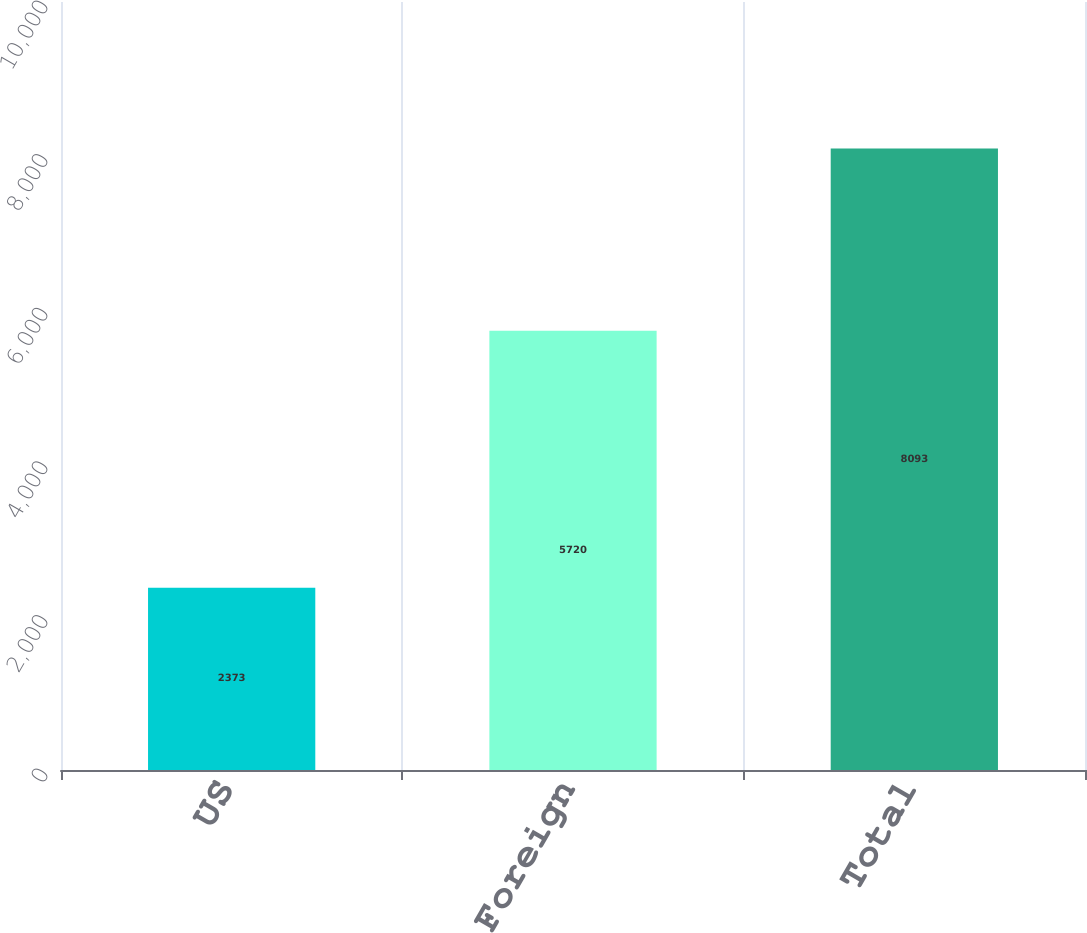Convert chart. <chart><loc_0><loc_0><loc_500><loc_500><bar_chart><fcel>US<fcel>Foreign<fcel>Total<nl><fcel>2373<fcel>5720<fcel>8093<nl></chart> 